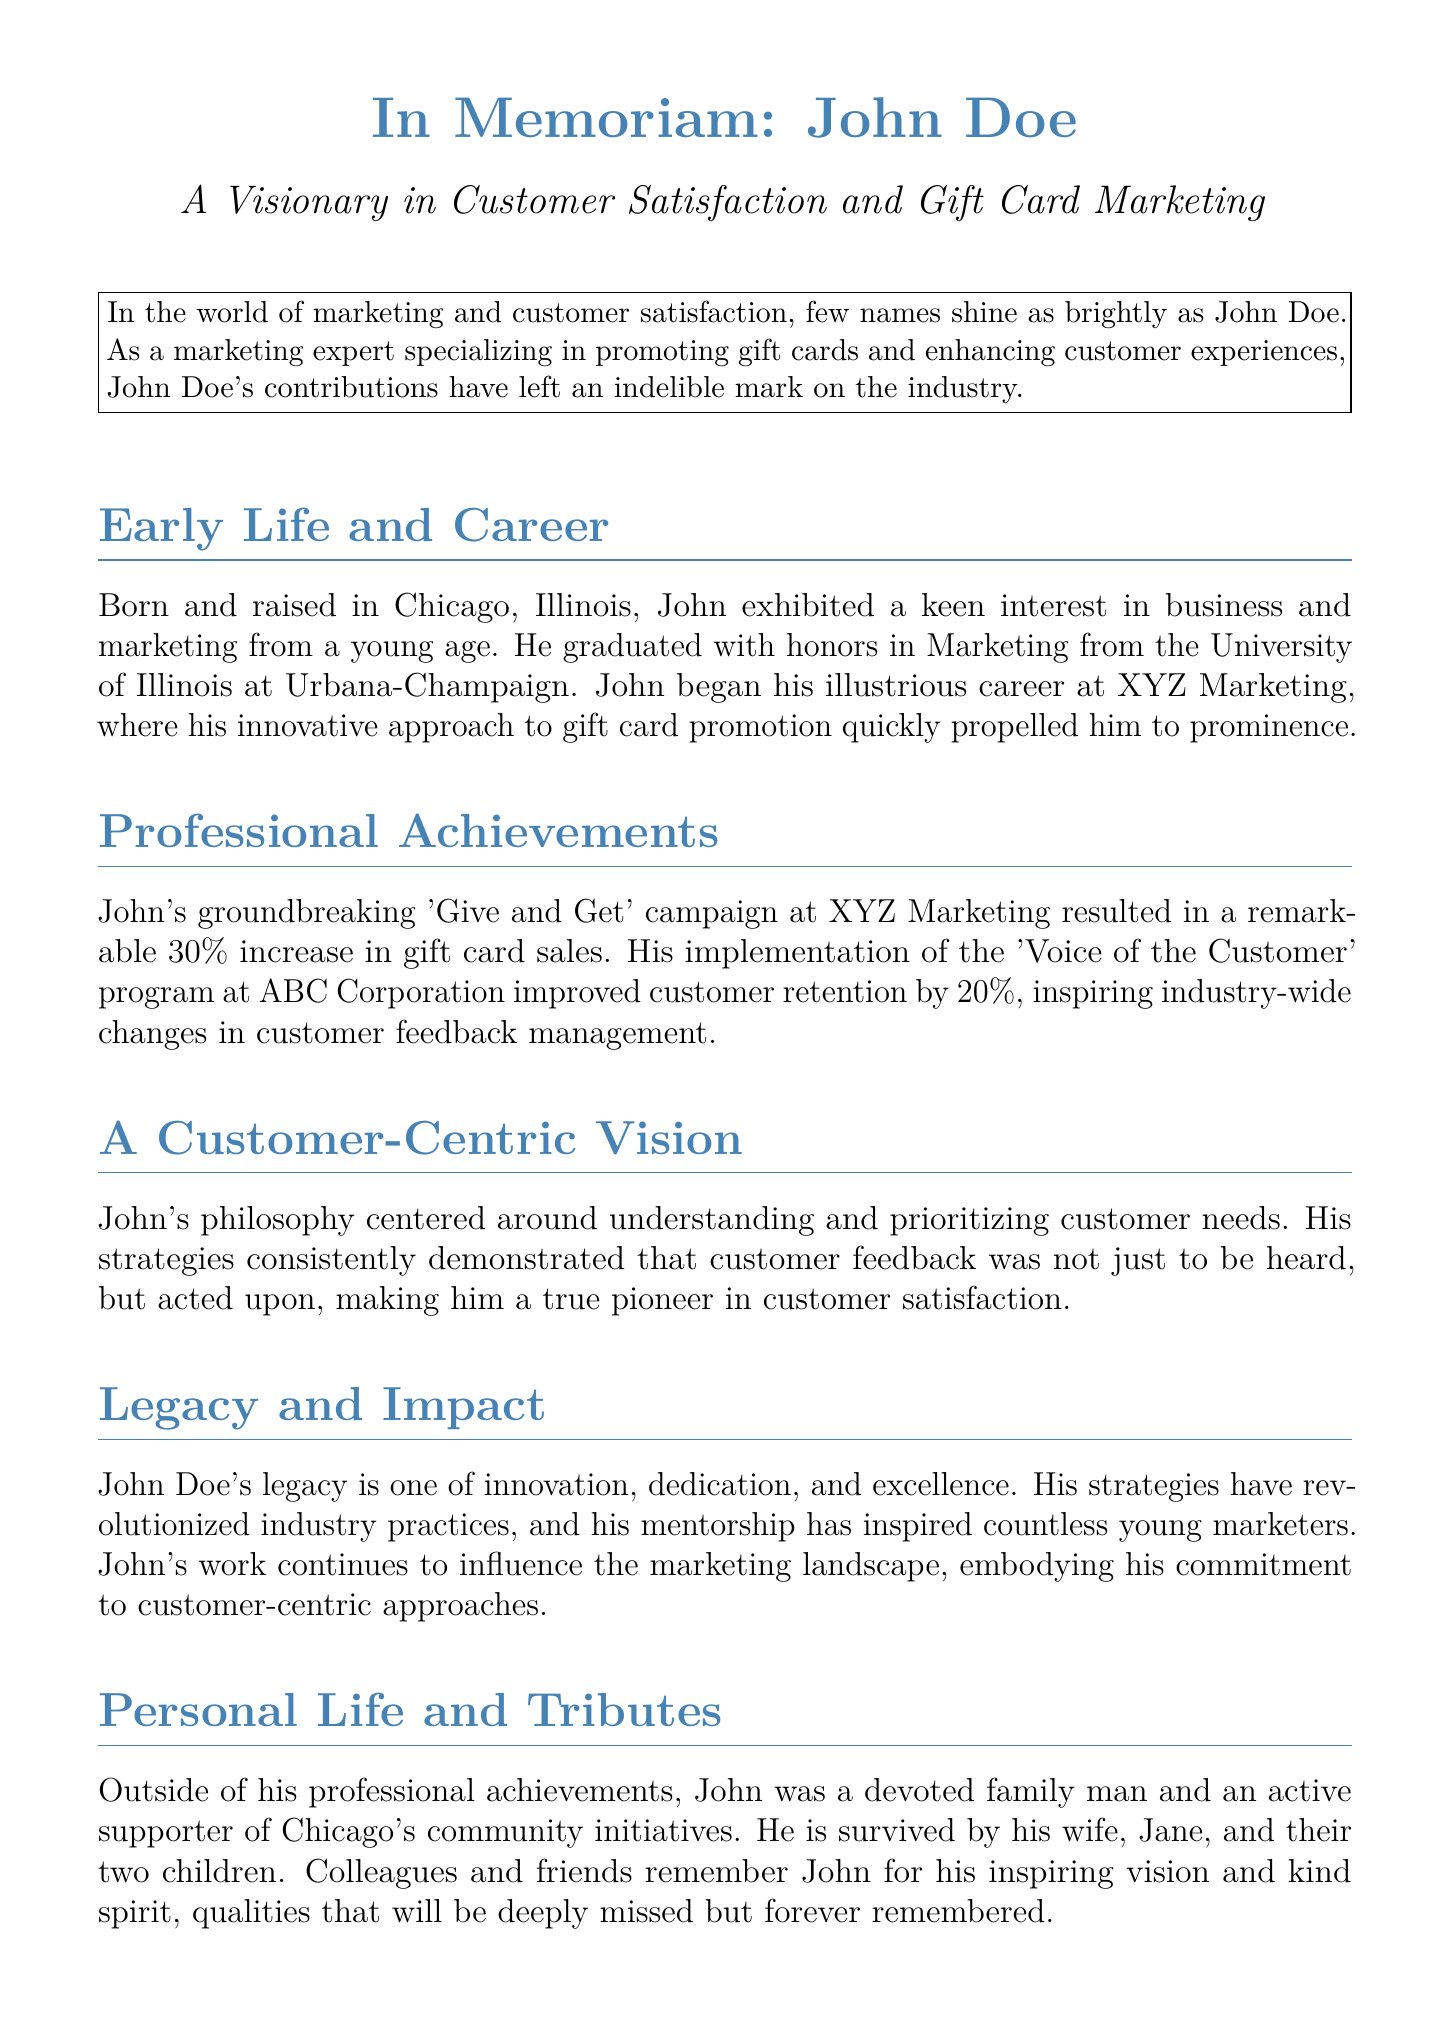What was John Doe's profession? John Doe specialized in promoting gift cards and enhancing customer experiences, indicating his role in marketing and customer satisfaction.
Answer: Marketing expert Where did John Doe graduate? The document states that John graduated with honors from the University of Illinois at Urbana-Champaign.
Answer: University of Illinois at Urbana-Champaign What campaign did John Doe implement at XYZ Marketing? The 'Give and Get' campaign led to a significant increase in gift card sales, showcasing his innovative strategies.
Answer: 'Give and Get' What was the percentage increase in gift card sales from John's campaign? The document mentions that John's campaign resulted in a remarkable 30% increase in gift card sales.
Answer: 30% Which program did John implement at ABC Corporation? The 'Voice of the Customer' program is referenced as a program that improved customer retention.
Answer: 'Voice of the Customer' What was John Doe's commitment that is mentioned in his legacy? The text emphasizes John's commitment to customer-centric approaches, highlighting his dedication to customer satisfaction.
Answer: Customer-centric approaches How many children did John Doe have? The document mentions that John is survived by his wife, Jane, and their two children.
Answer: Two children What was a significant aspect of John's personal life? The document highlights John as a devoted family man and an active supporter of community initiatives, indicating his involvement beyond work.
Answer: Devoted family man What characterized John Doe’s strategies? The document states that John's strategies consistently prioritized understanding and acting upon customer needs, which highlights his customer-centric focus.
Answer: Prioritized understanding of customer needs 